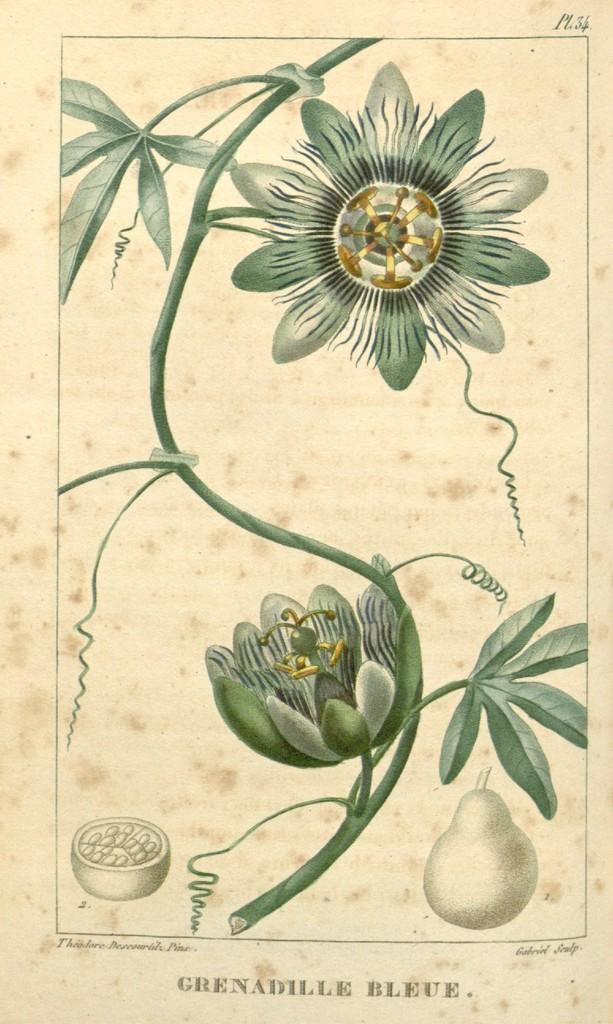What is depicted on the paper in the image? The paper contains a diagram of a flower. What elements are included in the diagram of the flower? The diagram includes fruit, leaves, and a stem. Is there any text on the paper? Yes, there is text on the paper. Can you see any animals at the zoo in the image? There is no zoo or animals present in the image; it features a paper with a diagram of a flower. 